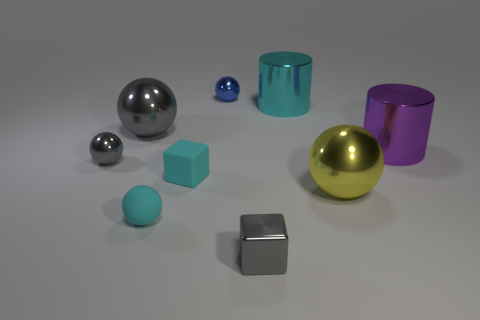Is the number of large spheres left of the large gray metallic ball less than the number of tiny rubber blocks that are to the right of the large cyan metallic cylinder?
Provide a short and direct response. No. The tiny shiny thing that is behind the large gray sphere in front of the cyan shiny thing is what shape?
Your answer should be compact. Sphere. Are there any other things that have the same color as the shiny block?
Provide a succinct answer. Yes. Do the tiny shiny cube and the tiny rubber block have the same color?
Ensure brevity in your answer.  No. What number of blue objects are either tiny spheres or small rubber blocks?
Offer a terse response. 1. Is the number of big cyan cylinders that are in front of the cyan sphere less than the number of big shiny cylinders?
Ensure brevity in your answer.  Yes. There is a cube that is on the left side of the tiny blue metal ball; how many big objects are right of it?
Make the answer very short. 3. What number of other things are there of the same size as the cyan sphere?
Provide a succinct answer. 4. What number of objects are either yellow matte cubes or tiny cyan rubber blocks left of the yellow metallic thing?
Offer a very short reply. 1. Are there fewer small yellow spheres than metal blocks?
Offer a very short reply. Yes. 